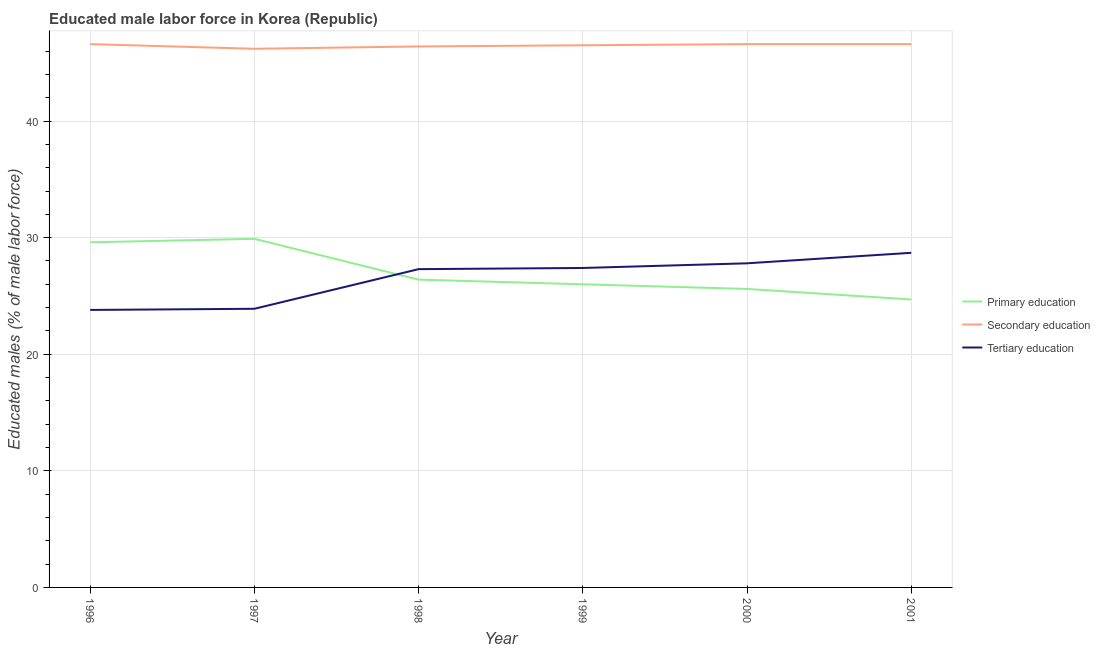What is the percentage of male labor force who received primary education in 2000?
Provide a short and direct response. 25.6. Across all years, what is the maximum percentage of male labor force who received primary education?
Provide a short and direct response. 29.9. Across all years, what is the minimum percentage of male labor force who received tertiary education?
Offer a terse response. 23.8. In which year was the percentage of male labor force who received tertiary education minimum?
Give a very brief answer. 1996. What is the total percentage of male labor force who received primary education in the graph?
Your response must be concise. 162.2. What is the difference between the percentage of male labor force who received tertiary education in 1997 and that in 1998?
Offer a very short reply. -3.4. What is the difference between the percentage of male labor force who received tertiary education in 1999 and the percentage of male labor force who received primary education in 2000?
Provide a short and direct response. 1.8. What is the average percentage of male labor force who received secondary education per year?
Your answer should be compact. 46.48. In the year 1998, what is the difference between the percentage of male labor force who received tertiary education and percentage of male labor force who received primary education?
Give a very brief answer. 0.9. What is the ratio of the percentage of male labor force who received secondary education in 1997 to that in 1998?
Make the answer very short. 1. Is the difference between the percentage of male labor force who received secondary education in 1996 and 1998 greater than the difference between the percentage of male labor force who received tertiary education in 1996 and 1998?
Your answer should be compact. Yes. What is the difference between the highest and the lowest percentage of male labor force who received primary education?
Your answer should be compact. 5.2. Is it the case that in every year, the sum of the percentage of male labor force who received primary education and percentage of male labor force who received secondary education is greater than the percentage of male labor force who received tertiary education?
Keep it short and to the point. Yes. Does the percentage of male labor force who received tertiary education monotonically increase over the years?
Offer a very short reply. Yes. Is the percentage of male labor force who received primary education strictly greater than the percentage of male labor force who received secondary education over the years?
Offer a very short reply. No. How many lines are there?
Give a very brief answer. 3. How many years are there in the graph?
Provide a short and direct response. 6. What is the difference between two consecutive major ticks on the Y-axis?
Your answer should be compact. 10. Does the graph contain any zero values?
Make the answer very short. No. What is the title of the graph?
Make the answer very short. Educated male labor force in Korea (Republic). What is the label or title of the Y-axis?
Make the answer very short. Educated males (% of male labor force). What is the Educated males (% of male labor force) of Primary education in 1996?
Ensure brevity in your answer.  29.6. What is the Educated males (% of male labor force) of Secondary education in 1996?
Your answer should be compact. 46.6. What is the Educated males (% of male labor force) in Tertiary education in 1996?
Keep it short and to the point. 23.8. What is the Educated males (% of male labor force) in Primary education in 1997?
Your answer should be compact. 29.9. What is the Educated males (% of male labor force) of Secondary education in 1997?
Provide a short and direct response. 46.2. What is the Educated males (% of male labor force) of Tertiary education in 1997?
Offer a terse response. 23.9. What is the Educated males (% of male labor force) of Primary education in 1998?
Ensure brevity in your answer.  26.4. What is the Educated males (% of male labor force) of Secondary education in 1998?
Provide a succinct answer. 46.4. What is the Educated males (% of male labor force) in Tertiary education in 1998?
Keep it short and to the point. 27.3. What is the Educated males (% of male labor force) of Secondary education in 1999?
Your answer should be compact. 46.5. What is the Educated males (% of male labor force) in Tertiary education in 1999?
Give a very brief answer. 27.4. What is the Educated males (% of male labor force) of Primary education in 2000?
Keep it short and to the point. 25.6. What is the Educated males (% of male labor force) of Secondary education in 2000?
Your answer should be compact. 46.6. What is the Educated males (% of male labor force) in Tertiary education in 2000?
Keep it short and to the point. 27.8. What is the Educated males (% of male labor force) of Primary education in 2001?
Offer a terse response. 24.7. What is the Educated males (% of male labor force) in Secondary education in 2001?
Your answer should be very brief. 46.6. What is the Educated males (% of male labor force) of Tertiary education in 2001?
Offer a very short reply. 28.7. Across all years, what is the maximum Educated males (% of male labor force) of Primary education?
Offer a terse response. 29.9. Across all years, what is the maximum Educated males (% of male labor force) in Secondary education?
Offer a terse response. 46.6. Across all years, what is the maximum Educated males (% of male labor force) in Tertiary education?
Keep it short and to the point. 28.7. Across all years, what is the minimum Educated males (% of male labor force) in Primary education?
Provide a succinct answer. 24.7. Across all years, what is the minimum Educated males (% of male labor force) of Secondary education?
Your response must be concise. 46.2. Across all years, what is the minimum Educated males (% of male labor force) in Tertiary education?
Make the answer very short. 23.8. What is the total Educated males (% of male labor force) of Primary education in the graph?
Provide a succinct answer. 162.2. What is the total Educated males (% of male labor force) in Secondary education in the graph?
Your answer should be very brief. 278.9. What is the total Educated males (% of male labor force) in Tertiary education in the graph?
Offer a very short reply. 158.9. What is the difference between the Educated males (% of male labor force) of Tertiary education in 1996 and that in 1997?
Keep it short and to the point. -0.1. What is the difference between the Educated males (% of male labor force) in Tertiary education in 1996 and that in 1998?
Your answer should be very brief. -3.5. What is the difference between the Educated males (% of male labor force) in Primary education in 1996 and that in 1999?
Give a very brief answer. 3.6. What is the difference between the Educated males (% of male labor force) in Secondary education in 1996 and that in 1999?
Your answer should be very brief. 0.1. What is the difference between the Educated males (% of male labor force) of Tertiary education in 1996 and that in 1999?
Your response must be concise. -3.6. What is the difference between the Educated males (% of male labor force) of Secondary education in 1996 and that in 2000?
Your answer should be compact. 0. What is the difference between the Educated males (% of male labor force) in Primary education in 1996 and that in 2001?
Keep it short and to the point. 4.9. What is the difference between the Educated males (% of male labor force) of Secondary education in 1996 and that in 2001?
Provide a short and direct response. 0. What is the difference between the Educated males (% of male labor force) in Primary education in 1997 and that in 1998?
Give a very brief answer. 3.5. What is the difference between the Educated males (% of male labor force) of Secondary education in 1997 and that in 1998?
Provide a succinct answer. -0.2. What is the difference between the Educated males (% of male labor force) in Tertiary education in 1997 and that in 1998?
Offer a very short reply. -3.4. What is the difference between the Educated males (% of male labor force) of Primary education in 1997 and that in 1999?
Make the answer very short. 3.9. What is the difference between the Educated males (% of male labor force) of Secondary education in 1997 and that in 2000?
Your answer should be very brief. -0.4. What is the difference between the Educated males (% of male labor force) in Tertiary education in 1997 and that in 2000?
Offer a very short reply. -3.9. What is the difference between the Educated males (% of male labor force) of Primary education in 1997 and that in 2001?
Provide a short and direct response. 5.2. What is the difference between the Educated males (% of male labor force) in Secondary education in 1997 and that in 2001?
Keep it short and to the point. -0.4. What is the difference between the Educated males (% of male labor force) of Primary education in 1998 and that in 1999?
Your answer should be very brief. 0.4. What is the difference between the Educated males (% of male labor force) in Primary education in 1998 and that in 2001?
Keep it short and to the point. 1.7. What is the difference between the Educated males (% of male labor force) in Secondary education in 1998 and that in 2001?
Offer a very short reply. -0.2. What is the difference between the Educated males (% of male labor force) in Primary education in 1999 and that in 2000?
Give a very brief answer. 0.4. What is the difference between the Educated males (% of male labor force) in Primary education in 1999 and that in 2001?
Keep it short and to the point. 1.3. What is the difference between the Educated males (% of male labor force) in Tertiary education in 1999 and that in 2001?
Your answer should be very brief. -1.3. What is the difference between the Educated males (% of male labor force) of Primary education in 2000 and that in 2001?
Make the answer very short. 0.9. What is the difference between the Educated males (% of male labor force) in Tertiary education in 2000 and that in 2001?
Offer a very short reply. -0.9. What is the difference between the Educated males (% of male labor force) in Primary education in 1996 and the Educated males (% of male labor force) in Secondary education in 1997?
Offer a very short reply. -16.6. What is the difference between the Educated males (% of male labor force) in Secondary education in 1996 and the Educated males (% of male labor force) in Tertiary education in 1997?
Ensure brevity in your answer.  22.7. What is the difference between the Educated males (% of male labor force) of Primary education in 1996 and the Educated males (% of male labor force) of Secondary education in 1998?
Make the answer very short. -16.8. What is the difference between the Educated males (% of male labor force) in Secondary education in 1996 and the Educated males (% of male labor force) in Tertiary education in 1998?
Your answer should be very brief. 19.3. What is the difference between the Educated males (% of male labor force) in Primary education in 1996 and the Educated males (% of male labor force) in Secondary education in 1999?
Make the answer very short. -16.9. What is the difference between the Educated males (% of male labor force) in Primary education in 1996 and the Educated males (% of male labor force) in Tertiary education in 2000?
Your answer should be very brief. 1.8. What is the difference between the Educated males (% of male labor force) of Primary education in 1997 and the Educated males (% of male labor force) of Secondary education in 1998?
Provide a short and direct response. -16.5. What is the difference between the Educated males (% of male labor force) in Secondary education in 1997 and the Educated males (% of male labor force) in Tertiary education in 1998?
Give a very brief answer. 18.9. What is the difference between the Educated males (% of male labor force) of Primary education in 1997 and the Educated males (% of male labor force) of Secondary education in 1999?
Offer a very short reply. -16.6. What is the difference between the Educated males (% of male labor force) in Secondary education in 1997 and the Educated males (% of male labor force) in Tertiary education in 1999?
Offer a terse response. 18.8. What is the difference between the Educated males (% of male labor force) in Primary education in 1997 and the Educated males (% of male labor force) in Secondary education in 2000?
Your answer should be very brief. -16.7. What is the difference between the Educated males (% of male labor force) in Primary education in 1997 and the Educated males (% of male labor force) in Secondary education in 2001?
Give a very brief answer. -16.7. What is the difference between the Educated males (% of male labor force) of Primary education in 1997 and the Educated males (% of male labor force) of Tertiary education in 2001?
Ensure brevity in your answer.  1.2. What is the difference between the Educated males (% of male labor force) in Secondary education in 1997 and the Educated males (% of male labor force) in Tertiary education in 2001?
Give a very brief answer. 17.5. What is the difference between the Educated males (% of male labor force) in Primary education in 1998 and the Educated males (% of male labor force) in Secondary education in 1999?
Offer a terse response. -20.1. What is the difference between the Educated males (% of male labor force) in Secondary education in 1998 and the Educated males (% of male labor force) in Tertiary education in 1999?
Give a very brief answer. 19. What is the difference between the Educated males (% of male labor force) in Primary education in 1998 and the Educated males (% of male labor force) in Secondary education in 2000?
Offer a very short reply. -20.2. What is the difference between the Educated males (% of male labor force) of Primary education in 1998 and the Educated males (% of male labor force) of Secondary education in 2001?
Make the answer very short. -20.2. What is the difference between the Educated males (% of male labor force) in Primary education in 1998 and the Educated males (% of male labor force) in Tertiary education in 2001?
Ensure brevity in your answer.  -2.3. What is the difference between the Educated males (% of male labor force) of Primary education in 1999 and the Educated males (% of male labor force) of Secondary education in 2000?
Ensure brevity in your answer.  -20.6. What is the difference between the Educated males (% of male labor force) of Primary education in 1999 and the Educated males (% of male labor force) of Tertiary education in 2000?
Offer a very short reply. -1.8. What is the difference between the Educated males (% of male labor force) in Primary education in 1999 and the Educated males (% of male labor force) in Secondary education in 2001?
Offer a terse response. -20.6. What is the difference between the Educated males (% of male labor force) of Primary education in 2000 and the Educated males (% of male labor force) of Secondary education in 2001?
Provide a short and direct response. -21. What is the average Educated males (% of male labor force) of Primary education per year?
Your answer should be compact. 27.03. What is the average Educated males (% of male labor force) in Secondary education per year?
Provide a short and direct response. 46.48. What is the average Educated males (% of male labor force) in Tertiary education per year?
Provide a short and direct response. 26.48. In the year 1996, what is the difference between the Educated males (% of male labor force) in Secondary education and Educated males (% of male labor force) in Tertiary education?
Provide a succinct answer. 22.8. In the year 1997, what is the difference between the Educated males (% of male labor force) of Primary education and Educated males (% of male labor force) of Secondary education?
Keep it short and to the point. -16.3. In the year 1997, what is the difference between the Educated males (% of male labor force) in Primary education and Educated males (% of male labor force) in Tertiary education?
Your answer should be very brief. 6. In the year 1997, what is the difference between the Educated males (% of male labor force) in Secondary education and Educated males (% of male labor force) in Tertiary education?
Your response must be concise. 22.3. In the year 1998, what is the difference between the Educated males (% of male labor force) of Primary education and Educated males (% of male labor force) of Secondary education?
Offer a very short reply. -20. In the year 1998, what is the difference between the Educated males (% of male labor force) in Primary education and Educated males (% of male labor force) in Tertiary education?
Your answer should be compact. -0.9. In the year 1998, what is the difference between the Educated males (% of male labor force) in Secondary education and Educated males (% of male labor force) in Tertiary education?
Your response must be concise. 19.1. In the year 1999, what is the difference between the Educated males (% of male labor force) in Primary education and Educated males (% of male labor force) in Secondary education?
Your answer should be compact. -20.5. In the year 1999, what is the difference between the Educated males (% of male labor force) of Secondary education and Educated males (% of male labor force) of Tertiary education?
Your answer should be compact. 19.1. In the year 2000, what is the difference between the Educated males (% of male labor force) in Primary education and Educated males (% of male labor force) in Tertiary education?
Keep it short and to the point. -2.2. In the year 2001, what is the difference between the Educated males (% of male labor force) in Primary education and Educated males (% of male labor force) in Secondary education?
Offer a very short reply. -21.9. In the year 2001, what is the difference between the Educated males (% of male labor force) of Primary education and Educated males (% of male labor force) of Tertiary education?
Keep it short and to the point. -4. What is the ratio of the Educated males (% of male labor force) in Primary education in 1996 to that in 1997?
Your answer should be very brief. 0.99. What is the ratio of the Educated males (% of male labor force) in Secondary education in 1996 to that in 1997?
Provide a succinct answer. 1.01. What is the ratio of the Educated males (% of male labor force) of Tertiary education in 1996 to that in 1997?
Your answer should be compact. 1. What is the ratio of the Educated males (% of male labor force) in Primary education in 1996 to that in 1998?
Make the answer very short. 1.12. What is the ratio of the Educated males (% of male labor force) of Secondary education in 1996 to that in 1998?
Your answer should be very brief. 1. What is the ratio of the Educated males (% of male labor force) of Tertiary education in 1996 to that in 1998?
Give a very brief answer. 0.87. What is the ratio of the Educated males (% of male labor force) in Primary education in 1996 to that in 1999?
Make the answer very short. 1.14. What is the ratio of the Educated males (% of male labor force) in Secondary education in 1996 to that in 1999?
Your answer should be compact. 1. What is the ratio of the Educated males (% of male labor force) in Tertiary education in 1996 to that in 1999?
Your answer should be compact. 0.87. What is the ratio of the Educated males (% of male labor force) in Primary education in 1996 to that in 2000?
Offer a very short reply. 1.16. What is the ratio of the Educated males (% of male labor force) of Tertiary education in 1996 to that in 2000?
Ensure brevity in your answer.  0.86. What is the ratio of the Educated males (% of male labor force) of Primary education in 1996 to that in 2001?
Offer a very short reply. 1.2. What is the ratio of the Educated males (% of male labor force) of Secondary education in 1996 to that in 2001?
Make the answer very short. 1. What is the ratio of the Educated males (% of male labor force) in Tertiary education in 1996 to that in 2001?
Offer a very short reply. 0.83. What is the ratio of the Educated males (% of male labor force) in Primary education in 1997 to that in 1998?
Provide a short and direct response. 1.13. What is the ratio of the Educated males (% of male labor force) in Tertiary education in 1997 to that in 1998?
Give a very brief answer. 0.88. What is the ratio of the Educated males (% of male labor force) of Primary education in 1997 to that in 1999?
Your answer should be very brief. 1.15. What is the ratio of the Educated males (% of male labor force) of Tertiary education in 1997 to that in 1999?
Provide a succinct answer. 0.87. What is the ratio of the Educated males (% of male labor force) of Primary education in 1997 to that in 2000?
Your answer should be compact. 1.17. What is the ratio of the Educated males (% of male labor force) in Tertiary education in 1997 to that in 2000?
Provide a short and direct response. 0.86. What is the ratio of the Educated males (% of male labor force) in Primary education in 1997 to that in 2001?
Your answer should be very brief. 1.21. What is the ratio of the Educated males (% of male labor force) in Secondary education in 1997 to that in 2001?
Your answer should be very brief. 0.99. What is the ratio of the Educated males (% of male labor force) of Tertiary education in 1997 to that in 2001?
Offer a terse response. 0.83. What is the ratio of the Educated males (% of male labor force) in Primary education in 1998 to that in 1999?
Provide a short and direct response. 1.02. What is the ratio of the Educated males (% of male labor force) in Tertiary education in 1998 to that in 1999?
Ensure brevity in your answer.  1. What is the ratio of the Educated males (% of male labor force) of Primary education in 1998 to that in 2000?
Your answer should be very brief. 1.03. What is the ratio of the Educated males (% of male labor force) of Secondary education in 1998 to that in 2000?
Provide a succinct answer. 1. What is the ratio of the Educated males (% of male labor force) in Tertiary education in 1998 to that in 2000?
Your answer should be very brief. 0.98. What is the ratio of the Educated males (% of male labor force) in Primary education in 1998 to that in 2001?
Keep it short and to the point. 1.07. What is the ratio of the Educated males (% of male labor force) of Secondary education in 1998 to that in 2001?
Provide a short and direct response. 1. What is the ratio of the Educated males (% of male labor force) in Tertiary education in 1998 to that in 2001?
Provide a succinct answer. 0.95. What is the ratio of the Educated males (% of male labor force) of Primary education in 1999 to that in 2000?
Provide a short and direct response. 1.02. What is the ratio of the Educated males (% of male labor force) of Tertiary education in 1999 to that in 2000?
Offer a terse response. 0.99. What is the ratio of the Educated males (% of male labor force) of Primary education in 1999 to that in 2001?
Provide a short and direct response. 1.05. What is the ratio of the Educated males (% of male labor force) in Secondary education in 1999 to that in 2001?
Your response must be concise. 1. What is the ratio of the Educated males (% of male labor force) in Tertiary education in 1999 to that in 2001?
Keep it short and to the point. 0.95. What is the ratio of the Educated males (% of male labor force) in Primary education in 2000 to that in 2001?
Give a very brief answer. 1.04. What is the ratio of the Educated males (% of male labor force) of Tertiary education in 2000 to that in 2001?
Your answer should be very brief. 0.97. What is the difference between the highest and the second highest Educated males (% of male labor force) in Primary education?
Keep it short and to the point. 0.3. What is the difference between the highest and the second highest Educated males (% of male labor force) of Tertiary education?
Your answer should be compact. 0.9. What is the difference between the highest and the lowest Educated males (% of male labor force) in Primary education?
Your answer should be very brief. 5.2. 